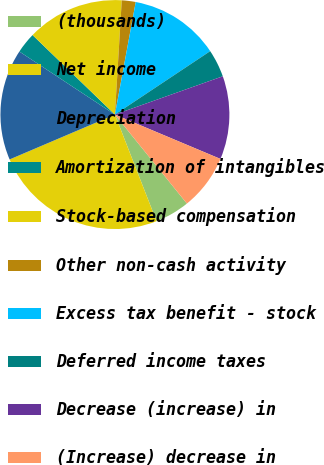<chart> <loc_0><loc_0><loc_500><loc_500><pie_chart><fcel>(thousands)<fcel>Net income<fcel>Depreciation<fcel>Amortization of intangibles<fcel>Stock-based compensation<fcel>Other non-cash activity<fcel>Excess tax benefit - stock<fcel>Deferred income taxes<fcel>Decrease (increase) in<fcel>(Increase) decrease in<nl><fcel>4.9%<fcel>24.51%<fcel>15.69%<fcel>2.94%<fcel>13.73%<fcel>1.96%<fcel>12.74%<fcel>3.92%<fcel>11.76%<fcel>7.84%<nl></chart> 